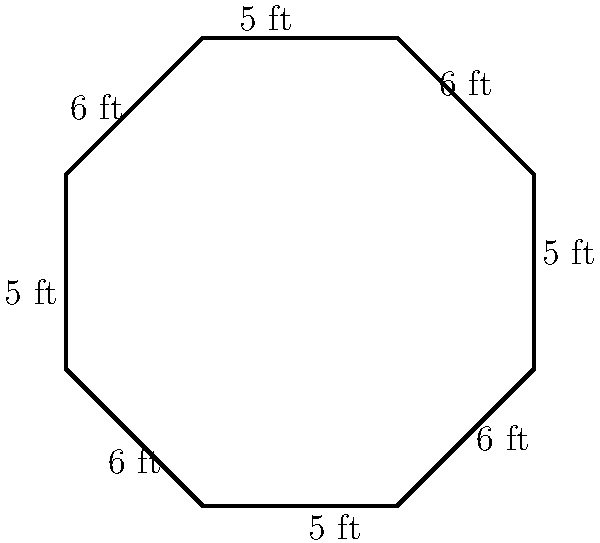In your wrestling gym, you have an octagonal wrestling ring with alternating side lengths of 6 feet and 5 feet, as shown in the diagram. What is the perimeter of this wrestling ring? To find the perimeter of the octagonal wrestling ring, we need to sum up the lengths of all sides. Let's approach this step-by-step:

1) We can see from the diagram that the octagon has alternating side lengths of 6 feet and 5 feet.

2) There are 8 sides in total in an octagon.

3) 4 sides have a length of 6 feet each:
   $4 \times 6 = 24$ feet

4) The other 4 sides have a length of 5 feet each:
   $4 \times 5 = 20$ feet

5) To get the total perimeter, we add these together:
   $24 + 20 = 44$ feet

Therefore, the perimeter of the octagonal wrestling ring is 44 feet.
Answer: 44 feet 